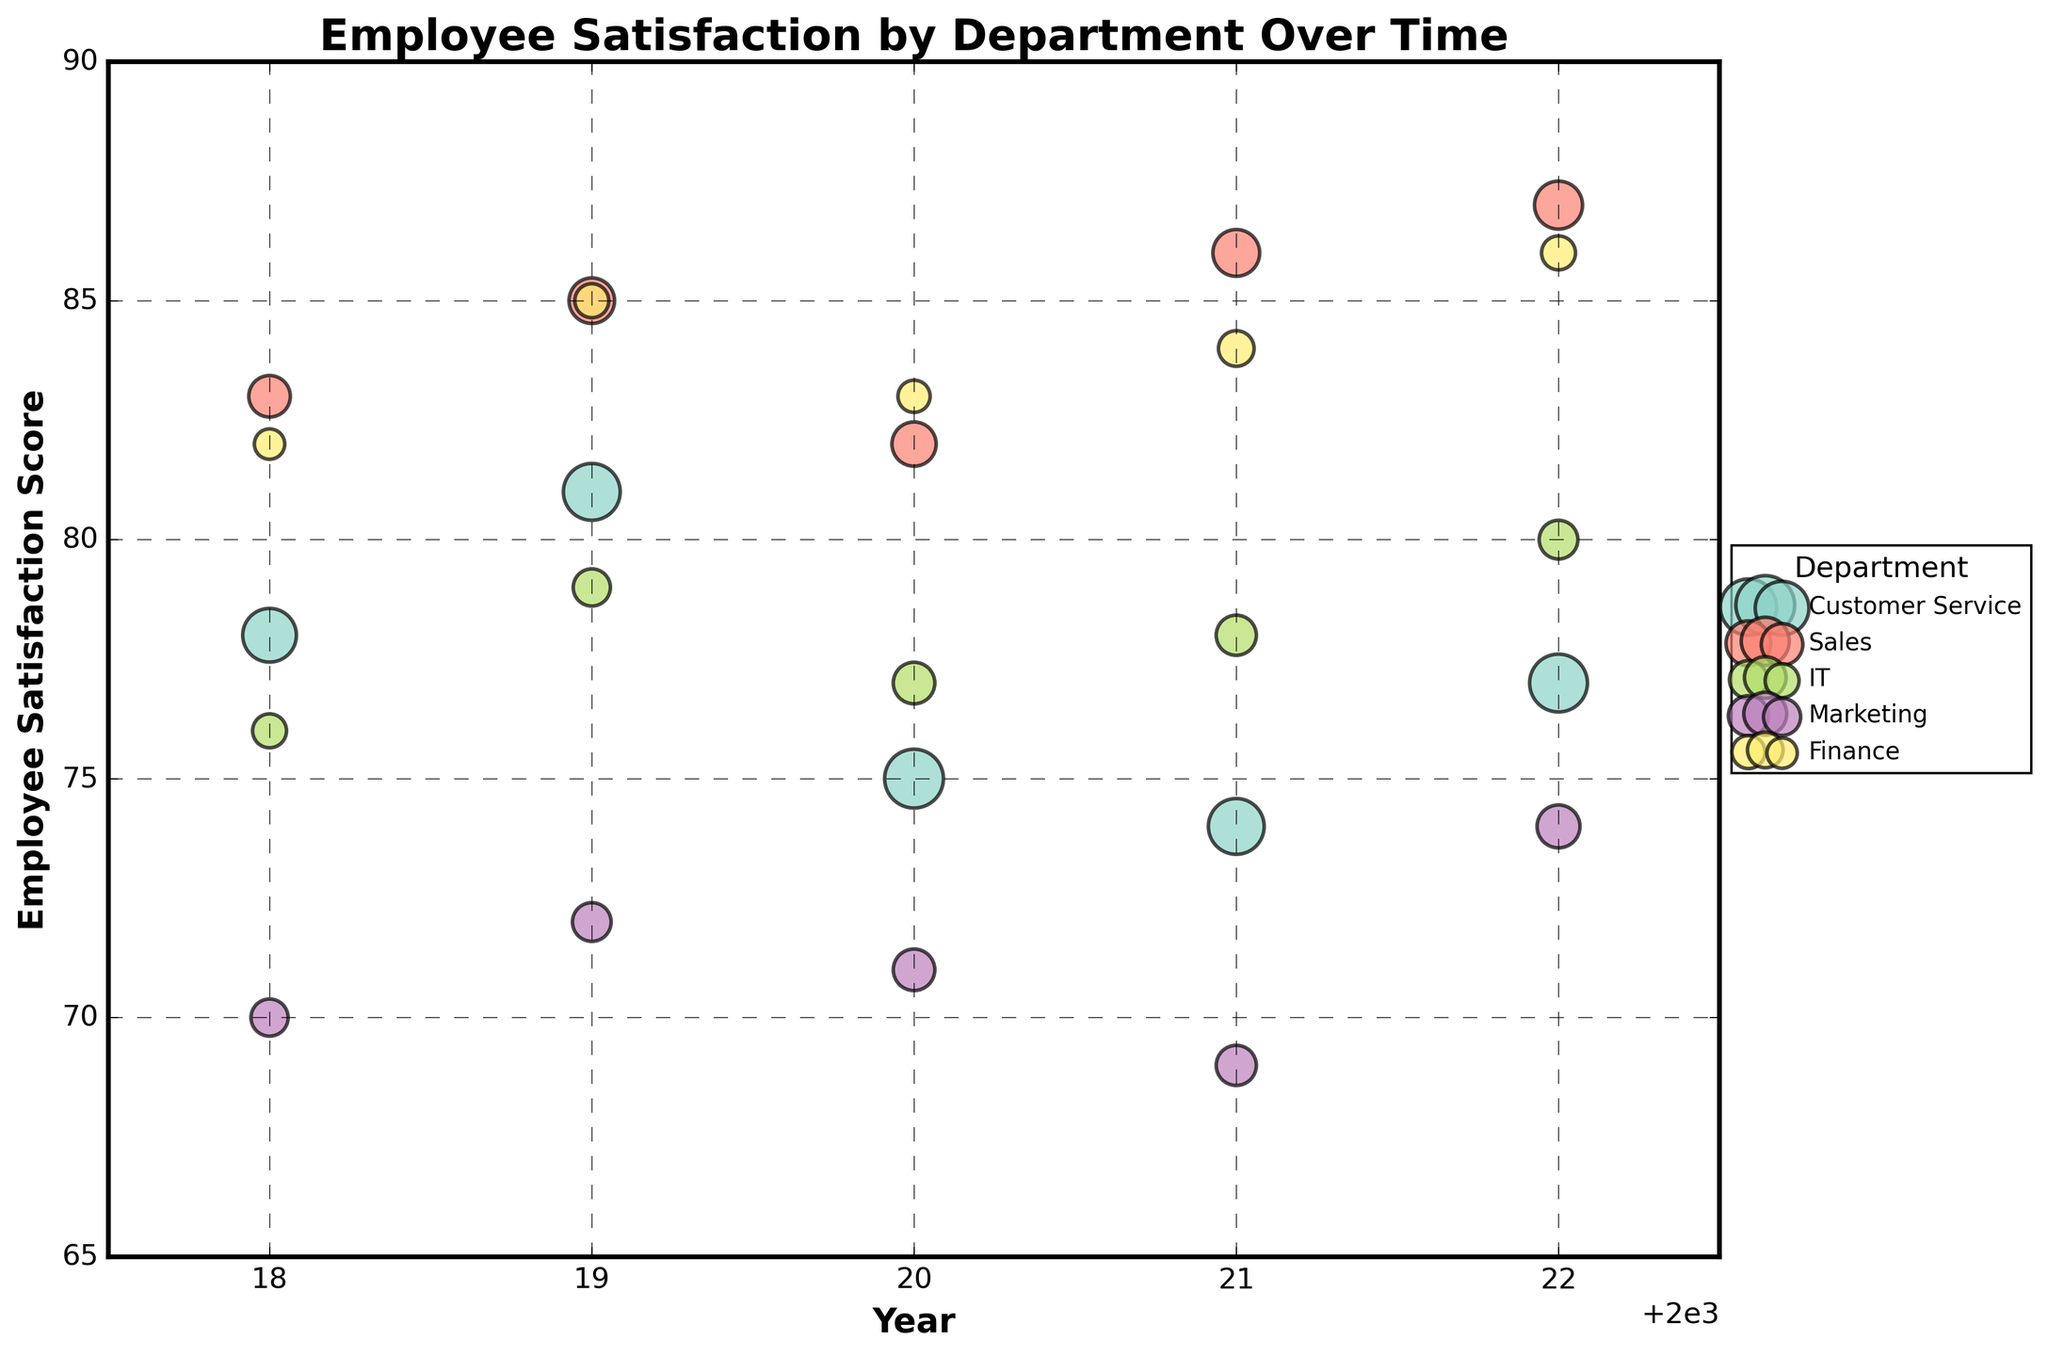What is the title of the bubble chart? The title is usually located at the top of the chart in a prominent font. In this case, it reads "Employee Satisfaction by Department Over Time."
Answer: Employee Satisfaction by Department Over Time What does the x-axis represent? The x-axis usually indicates one of the variables being measured. Here, it represents the "Year" from 2018 to 2022.
Answer: Year What does the y-axis represent? The y-axis shows another variable being measured. In this case, it represents "Employee Satisfaction Score."
Answer: Employee Satisfaction Score Which department has the highest Employee Satisfaction Score in 2022? We look at the data points in the year 2022 on the x-axis and find the highest y-value (Employee Satisfaction Score). The highest score in 2022 is 87 for the Sales department.
Answer: Sales How many departments are plotted in the chart? The chart legend usually indicates the number of unique groups. Here, there are five departments shown in the legend: Customer Service, Sales, IT, Marketing, and Finance.
Answer: 5 Which department shows the most improvement in Employee Satisfaction Score from 2018 to 2022? By examining the scores for each department from 2018 to 2022, we can calculate the change for each. The Sales department improved from 83 in 2018 to 87 in 2022, a change of +4, which is the highest improvement.
Answer: Sales What is the average Employee Satisfaction Score for the IT department over these years? We sum the scores for IT (76, 79, 77, 78, 80) and then divide by the number of years (5). The calculation is (76 + 79 + 77 + 78 + 80) / 5 = 78.
Answer: 78 Which department had the largest number of employees in 2020? We look for the largest bubble in the year 2020. The largest bubble represents Customer Service with an Employee Count of 30.
Answer: Customer Service Compare the Employee Satisfaction Scores of IT and Finance in 2019. Which is higher? In 2019, the Employee Satisfaction Score for IT is 79, and for Finance, it is 85. Comparing these, Finance has the higher score.
Answer: Finance For the Marketing department, did the Employee Satisfaction Score ever fall below 70 between 2018 and 2022? By visually inspecting the y-axis values for Marketing from 2018 to 2022, we see that the lowest score is 69 in 2021, which is below 70.
Answer: Yes Which department has shown the most variable Employee Satisfaction Scores over the years? We examine the fluctuation range for each department. Marketing scores range from a low of 69 to a high of 74, a total range of 5, which suggests the most variability.
Answer: Marketing 